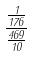Convert formula to latex. <formula><loc_0><loc_0><loc_500><loc_500>\frac { \frac { 1 } { 1 7 6 } } { \frac { 4 6 9 } { 1 0 } }</formula> 